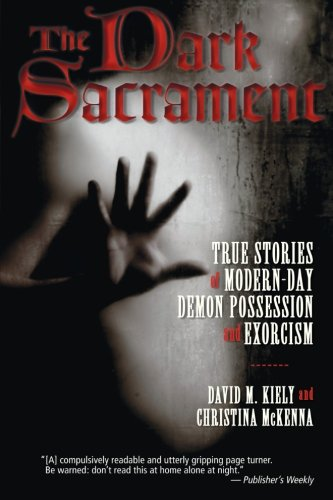Can you tell if this book uses any specific case studies or personal narratives? The subtitle 'True Stories of Modern-Day Demon Possession and Exorcism' suggests that the book includes various real-life case studies or narratives to explore its central themes. Are there any notable cases mentioned in the book that became famous or widely discussed? While specific cases cannot be confirmed without content examination, such books often highlight particularly dramatic or well-documented incidents to underline the reality and severity of such occurrences. 